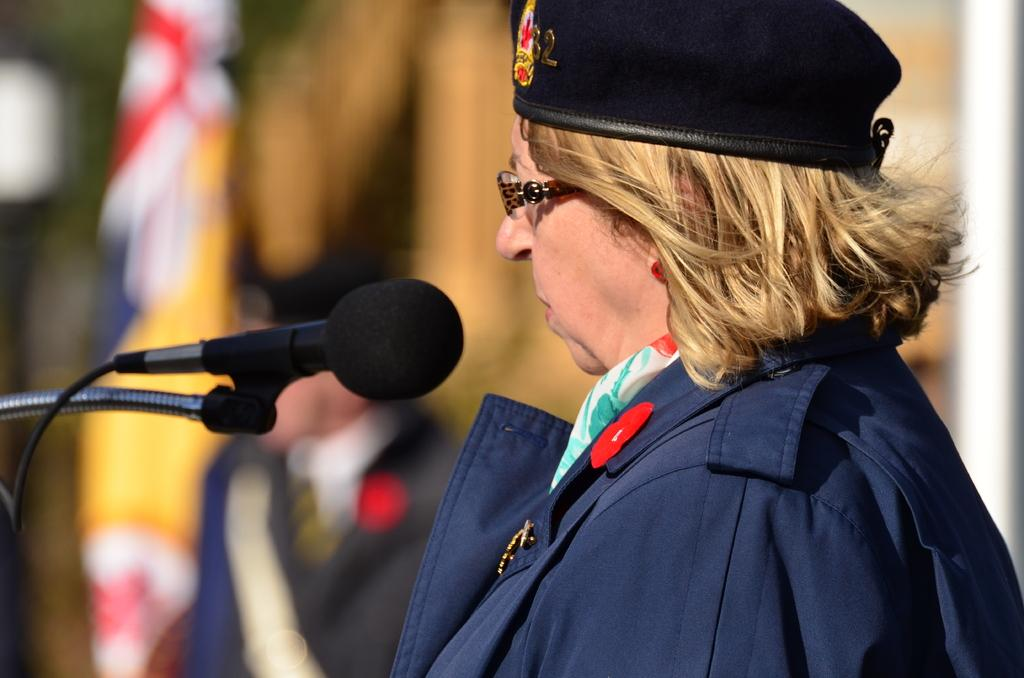Who is the main subject in the image? There is a woman in the image. What object is in front of the woman? There is a microphone (mic) in front of the woman. What can be seen in the background of the image? There is a flag visible in the background. Can you describe the man in the background? There is a man sitting in the background. How does the woman use the hook to adjust the appliance in the image? There is no hook or appliance present in the image. 